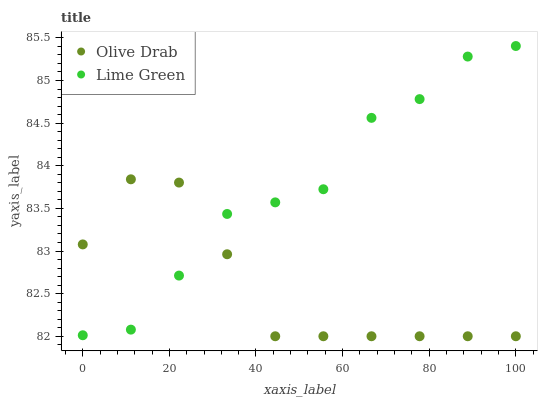Does Olive Drab have the minimum area under the curve?
Answer yes or no. Yes. Does Lime Green have the maximum area under the curve?
Answer yes or no. Yes. Does Olive Drab have the maximum area under the curve?
Answer yes or no. No. Is Olive Drab the smoothest?
Answer yes or no. Yes. Is Lime Green the roughest?
Answer yes or no. Yes. Is Olive Drab the roughest?
Answer yes or no. No. Does Olive Drab have the lowest value?
Answer yes or no. Yes. Does Lime Green have the highest value?
Answer yes or no. Yes. Does Olive Drab have the highest value?
Answer yes or no. No. Does Olive Drab intersect Lime Green?
Answer yes or no. Yes. Is Olive Drab less than Lime Green?
Answer yes or no. No. Is Olive Drab greater than Lime Green?
Answer yes or no. No. 